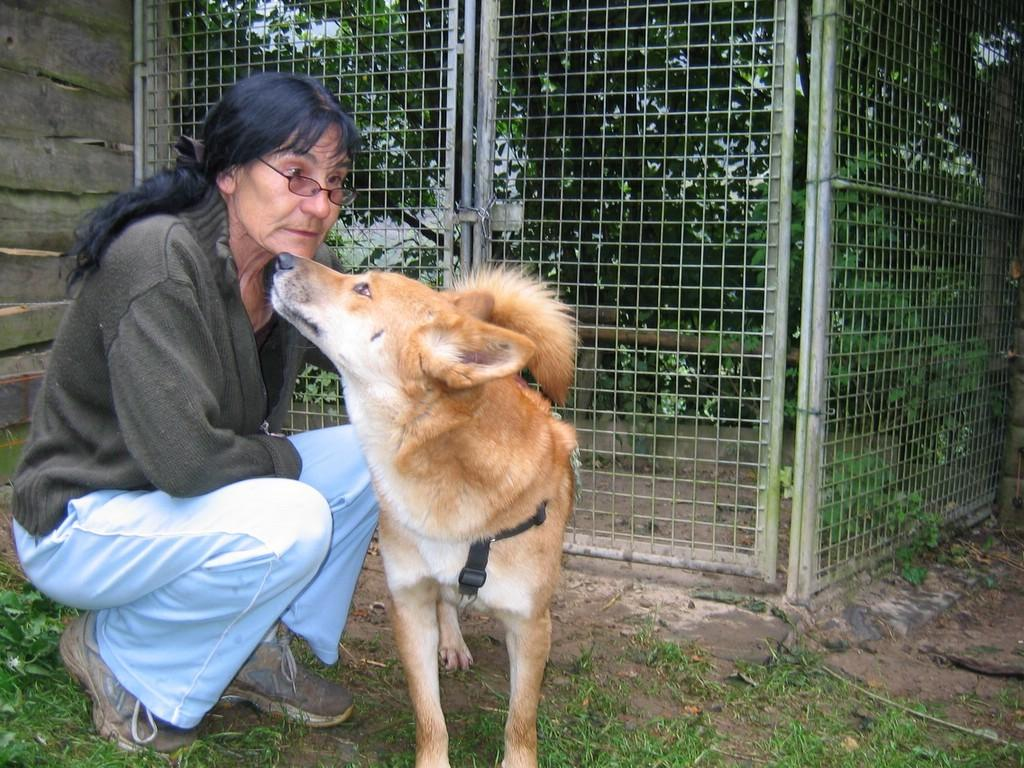What animal can be seen in the image? There is a dog in the image. Who is present in the image besides the dog? There is a woman in the image. What is the woman doing in the image? The woman is squatting on a grassland. What can be seen in the background of the image? There is fencing and trees in the background of the image. What type of sponge is the dog using to clean the sidewalk in the image? There is no sidewalk or sponge present in the image. Is the dog wearing a collar in the image? The image does not show the dog wearing a collar. 